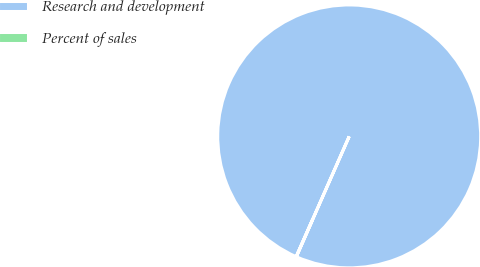Convert chart. <chart><loc_0><loc_0><loc_500><loc_500><pie_chart><fcel>Research and development<fcel>Percent of sales<nl><fcel>99.99%<fcel>0.01%<nl></chart> 